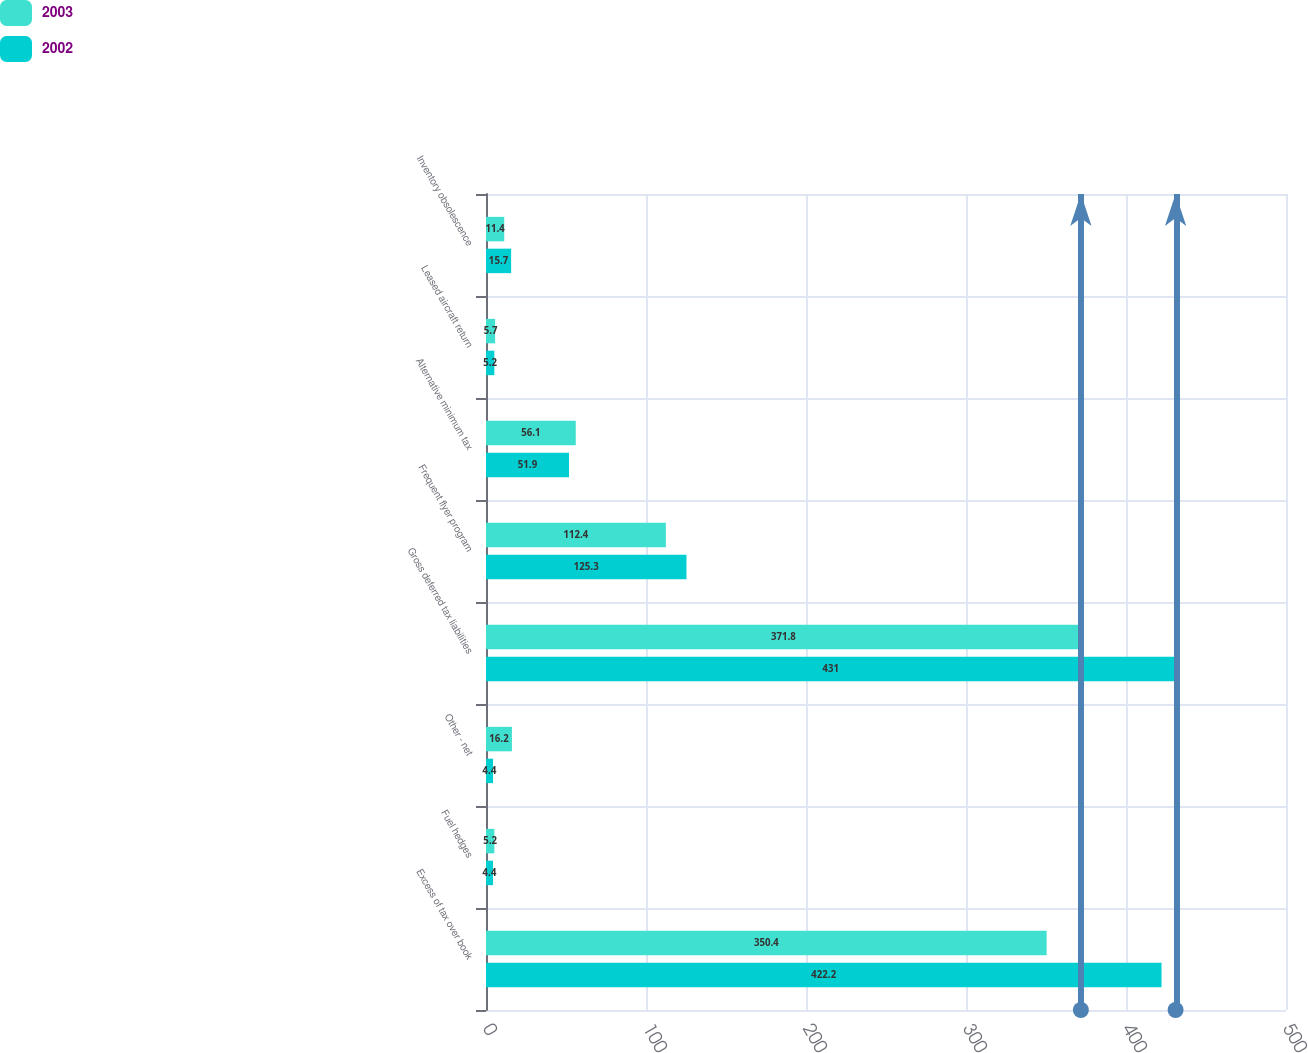Convert chart to OTSL. <chart><loc_0><loc_0><loc_500><loc_500><stacked_bar_chart><ecel><fcel>Excess of tax over book<fcel>Fuel hedges<fcel>Other - net<fcel>Gross deferred tax liabilities<fcel>Frequent flyer program<fcel>Alternative minimum tax<fcel>Leased aircraft return<fcel>Inventory obsolescence<nl><fcel>2003<fcel>350.4<fcel>5.2<fcel>16.2<fcel>371.8<fcel>112.4<fcel>56.1<fcel>5.7<fcel>11.4<nl><fcel>2002<fcel>422.2<fcel>4.4<fcel>4.4<fcel>431<fcel>125.3<fcel>51.9<fcel>5.2<fcel>15.7<nl></chart> 